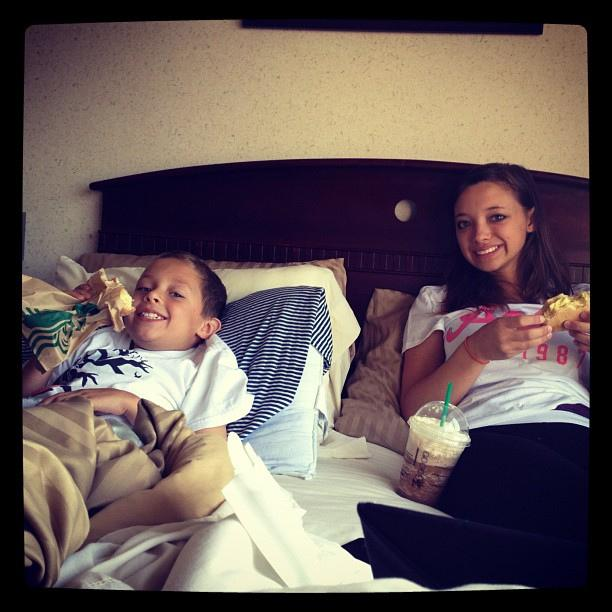What food place did the children get their food from? Please explain your reasoning. starbucks. There is the whipped-coffee-in-plastic cup next to the girl. 